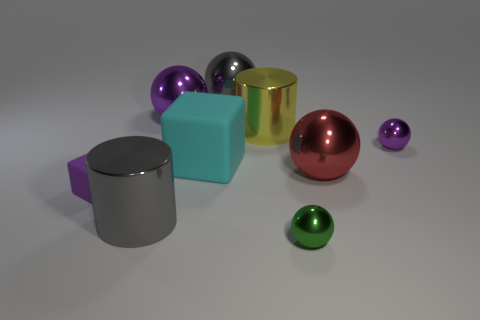What shape is the large thing that is the same color as the tiny rubber cube?
Provide a short and direct response. Sphere. What number of other objects are the same shape as the small purple shiny object?
Keep it short and to the point. 4. What is the size of the purple matte block?
Ensure brevity in your answer.  Small. What number of objects are small green spheres or big purple shiny things?
Make the answer very short. 2. There is a purple shiny sphere left of the red metal ball; what size is it?
Your answer should be very brief. Large. What color is the big shiny object that is in front of the yellow thing and behind the gray cylinder?
Provide a succinct answer. Red. Do the green sphere that is in front of the large red metal ball and the small block have the same material?
Keep it short and to the point. No. Does the small rubber thing have the same color as the small shiny thing that is behind the large red metallic sphere?
Make the answer very short. Yes. There is a big red shiny thing; are there any matte objects on the right side of it?
Your response must be concise. No. There is a cylinder in front of the large cyan matte object; is its size the same as the rubber block right of the purple rubber cube?
Offer a terse response. Yes. 